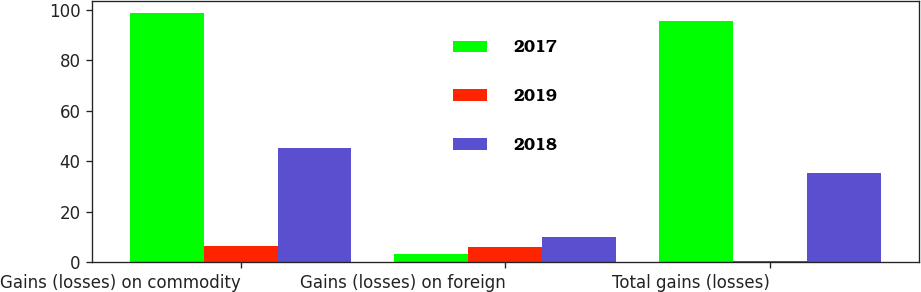Convert chart. <chart><loc_0><loc_0><loc_500><loc_500><stacked_bar_chart><ecel><fcel>Gains (losses) on commodity<fcel>Gains (losses) on foreign<fcel>Total gains (losses)<nl><fcel>2017<fcel>98.6<fcel>3<fcel>95.6<nl><fcel>2019<fcel>6.5<fcel>5.9<fcel>0.6<nl><fcel>2018<fcel>45.2<fcel>9.8<fcel>35.4<nl></chart> 